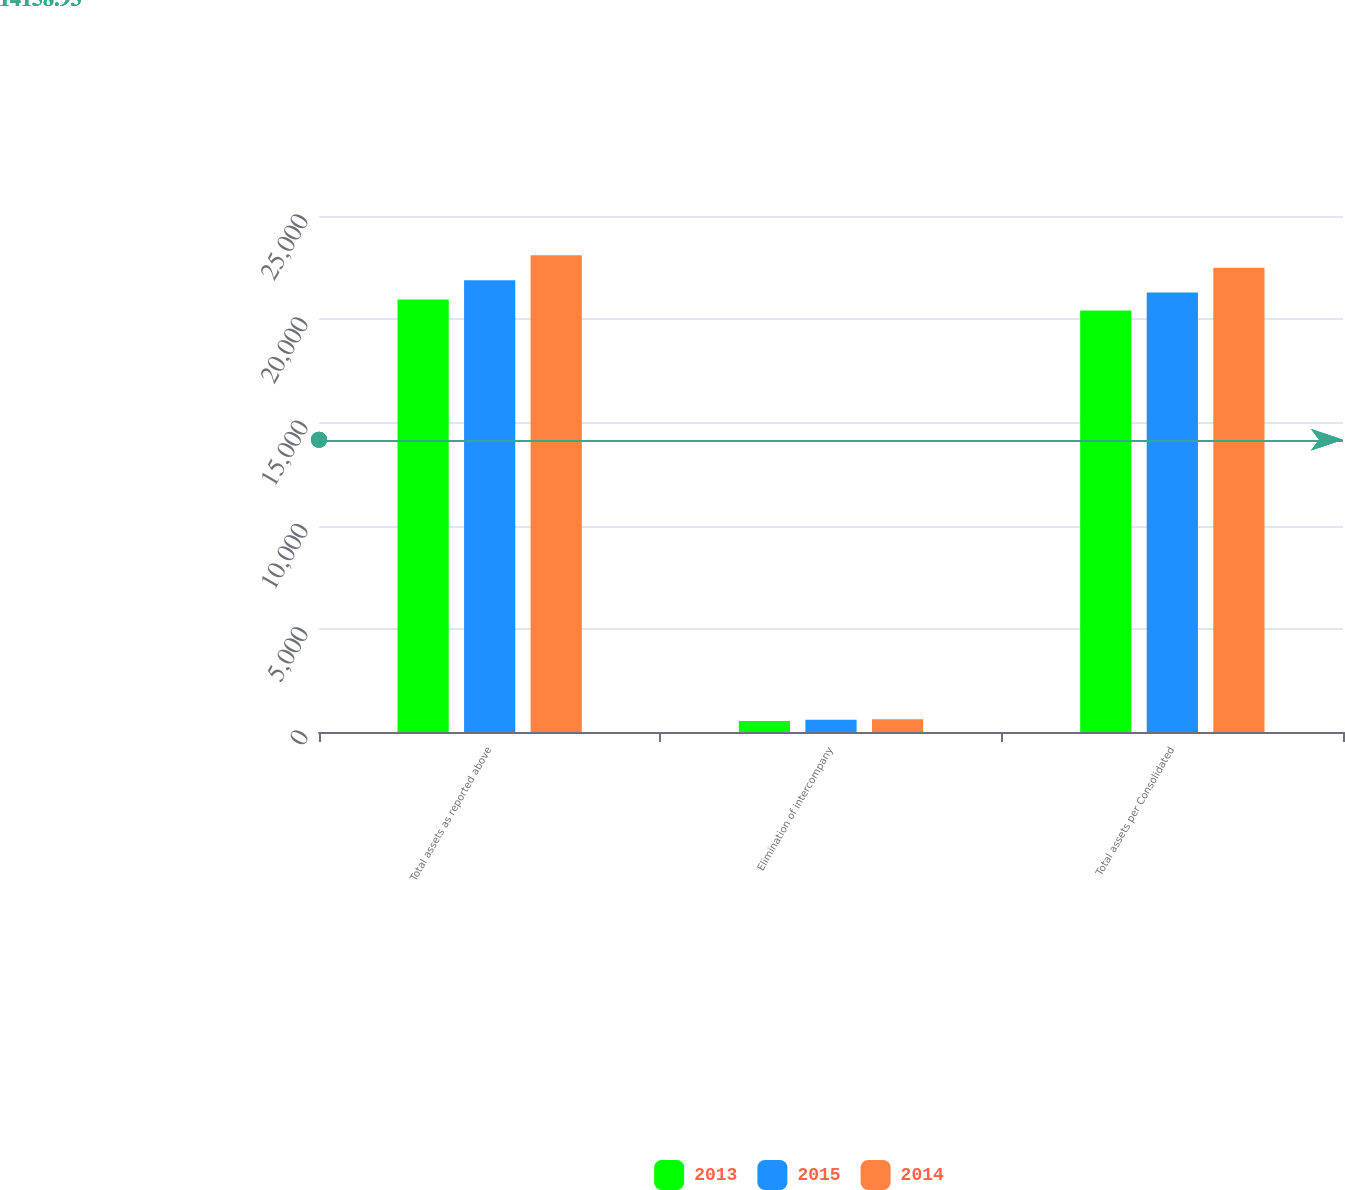Convert chart to OTSL. <chart><loc_0><loc_0><loc_500><loc_500><stacked_bar_chart><ecel><fcel>Total assets as reported above<fcel>Elimination of intercompany<fcel>Total assets per Consolidated<nl><fcel>2013<fcel>20958<fcel>539<fcel>20419<nl><fcel>2015<fcel>21888<fcel>591<fcel>21297<nl><fcel>2014<fcel>23102<fcel>612<fcel>22490<nl></chart> 